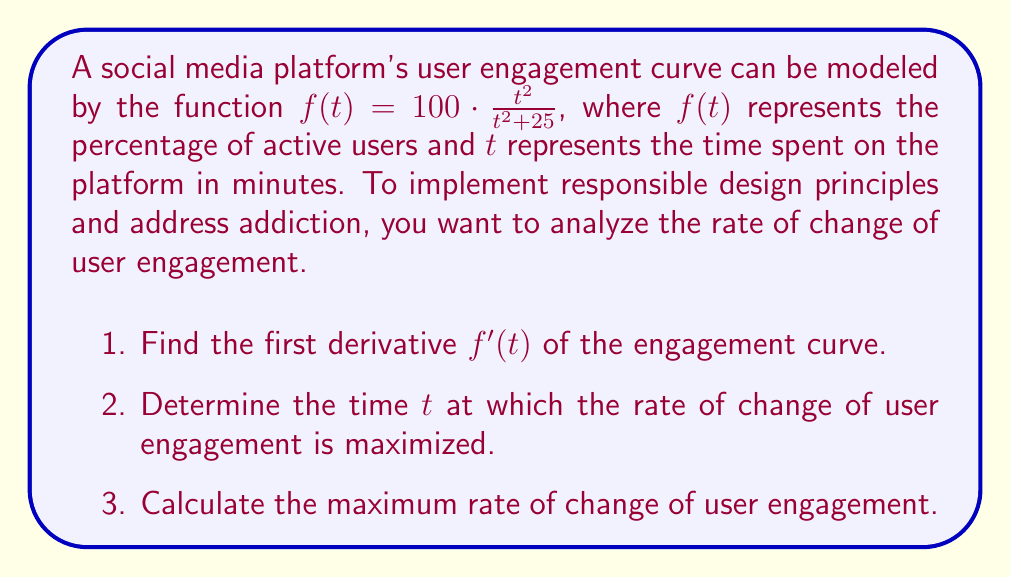Could you help me with this problem? 1. To find the first derivative $f'(t)$, we use the quotient rule:

   $$f'(t) = 100 \cdot \frac{(t^2 + 25) \cdot 2t - t^2 \cdot 2t}{(t^2 + 25)^2}$$

   Simplifying:
   $$f'(t) = 100 \cdot \frac{2t^3 + 50t - 2t^3}{(t^2 + 25)^2} = \frac{5000t}{(t^2 + 25)^2}$$

2. To find the time $t$ at which the rate of change is maximized, we need to find the critical points of $f'(t)$. We do this by setting $f''(t) = 0$ and solving for $t$.

   $$f''(t) = \frac{5000(t^2 + 25)^2 - 5000t \cdot 2(t^2 + 25) \cdot 2t}{(t^2 + 25)^4}$$

   Simplifying and setting equal to zero:
   $$\frac{5000((t^2 + 25)^2 - 4t^2(t^2 + 25))}{(t^2 + 25)^4} = 0$$

   The numerator equals zero when:
   $$(t^2 + 25)^2 - 4t^2(t^2 + 25) = 0$$
   $$t^4 + 50t^2 + 625 - 4t^4 - 100t^2 = 0$$
   $$-3t^4 - 50t^2 + 625 = 0$$
   $$-3(t^4 + \frac{50}{3}t^2 - \frac{625}{3}) = 0$$
   $$t^4 + \frac{50}{3}t^2 - \frac{625}{3} = 0$$

   Let $u = t^2$, then:
   $$u^2 + \frac{50}{3}u - \frac{625}{3} = 0$$

   Solving this quadratic equation:
   $$u = \frac{-50 \pm \sqrt{2500 + 7500}}{6} = \frac{-50 \pm \sqrt{10000}}{6} = \frac{-50 \pm 100}{6}$$

   The positive solution is $u = \frac{50}{6}$, so $t^2 = \frac{50}{6}$

   $$t = \sqrt{\frac{50}{6}} = \frac{5\sqrt{2}}{\sqrt{3}}$$

3. The maximum rate of change occurs at $t = \frac{5\sqrt{2}}{\sqrt{3}}$. Substituting this into $f'(t)$:

   $$f'(\frac{5\sqrt{2}}{\sqrt{3}}) = \frac{5000 \cdot \frac{5\sqrt{2}}{\sqrt{3}}}{(\frac{50}{6} + 25)^2} = \frac{5000 \cdot \frac{5\sqrt{2}}{\sqrt{3}}}{(\frac{200}{6})^2} = \frac{5000 \cdot \frac{5\sqrt{2}}{\sqrt{3}}}{(\frac{100}{3})^2}$$

   $$= \frac{25000\sqrt{6}}{10000} = \frac{5\sqrt{6}}{2} \approx 6.12$$
Answer: $f'(t) = \frac{5000t}{(t^2 + 25)^2}$; $t = \frac{5\sqrt{2}}{\sqrt{3}}$; Maximum rate of change $\approx 6.12\%$ per minute 